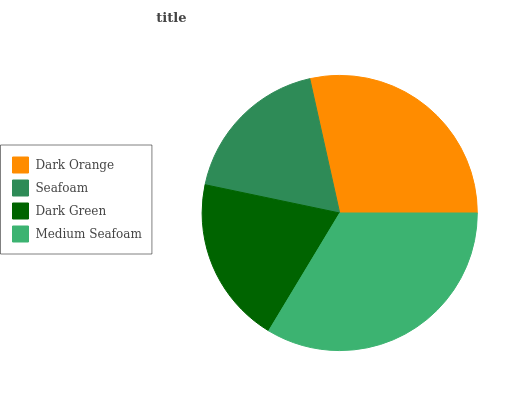Is Seafoam the minimum?
Answer yes or no. Yes. Is Medium Seafoam the maximum?
Answer yes or no. Yes. Is Dark Green the minimum?
Answer yes or no. No. Is Dark Green the maximum?
Answer yes or no. No. Is Dark Green greater than Seafoam?
Answer yes or no. Yes. Is Seafoam less than Dark Green?
Answer yes or no. Yes. Is Seafoam greater than Dark Green?
Answer yes or no. No. Is Dark Green less than Seafoam?
Answer yes or no. No. Is Dark Orange the high median?
Answer yes or no. Yes. Is Dark Green the low median?
Answer yes or no. Yes. Is Medium Seafoam the high median?
Answer yes or no. No. Is Medium Seafoam the low median?
Answer yes or no. No. 